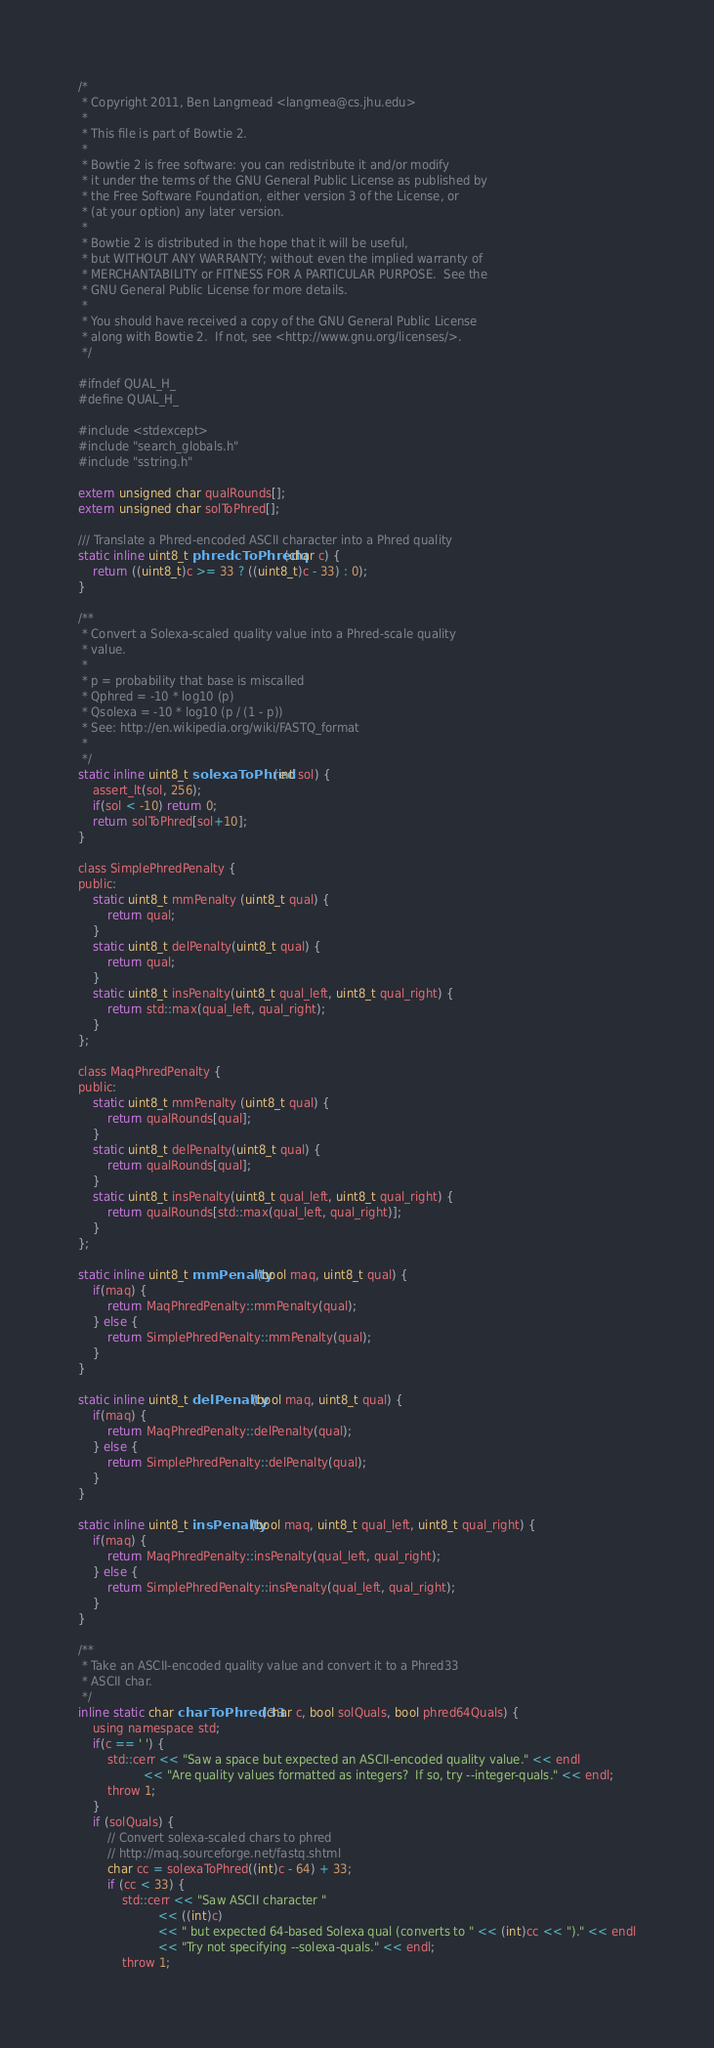Convert code to text. <code><loc_0><loc_0><loc_500><loc_500><_C_>/*
 * Copyright 2011, Ben Langmead <langmea@cs.jhu.edu>
 *
 * This file is part of Bowtie 2.
 *
 * Bowtie 2 is free software: you can redistribute it and/or modify
 * it under the terms of the GNU General Public License as published by
 * the Free Software Foundation, either version 3 of the License, or
 * (at your option) any later version.
 *
 * Bowtie 2 is distributed in the hope that it will be useful,
 * but WITHOUT ANY WARRANTY; without even the implied warranty of
 * MERCHANTABILITY or FITNESS FOR A PARTICULAR PURPOSE.  See the
 * GNU General Public License for more details.
 *
 * You should have received a copy of the GNU General Public License
 * along with Bowtie 2.  If not, see <http://www.gnu.org/licenses/>.
 */

#ifndef QUAL_H_
#define QUAL_H_

#include <stdexcept>
#include "search_globals.h"
#include "sstring.h"

extern unsigned char qualRounds[];
extern unsigned char solToPhred[];

/// Translate a Phred-encoded ASCII character into a Phred quality
static inline uint8_t phredcToPhredq(char c) {
	return ((uint8_t)c >= 33 ? ((uint8_t)c - 33) : 0);
}

/**
 * Convert a Solexa-scaled quality value into a Phred-scale quality
 * value.
 *
 * p = probability that base is miscalled
 * Qphred = -10 * log10 (p)
 * Qsolexa = -10 * log10 (p / (1 - p))
 * See: http://en.wikipedia.org/wiki/FASTQ_format
 *
 */
static inline uint8_t solexaToPhred(int sol) {
	assert_lt(sol, 256);
	if(sol < -10) return 0;
	return solToPhred[sol+10];
}

class SimplePhredPenalty {
public:
	static uint8_t mmPenalty (uint8_t qual) {
		return qual;
	}
	static uint8_t delPenalty(uint8_t qual) {
		return qual;
	}
	static uint8_t insPenalty(uint8_t qual_left, uint8_t qual_right) {
		return std::max(qual_left, qual_right);
	}
};

class MaqPhredPenalty {
public:
	static uint8_t mmPenalty (uint8_t qual) {
		return qualRounds[qual];
	}
	static uint8_t delPenalty(uint8_t qual) {
		return qualRounds[qual];
	}
	static uint8_t insPenalty(uint8_t qual_left, uint8_t qual_right) {
		return qualRounds[std::max(qual_left, qual_right)];
	}
};

static inline uint8_t mmPenalty(bool maq, uint8_t qual) {
	if(maq) {
		return MaqPhredPenalty::mmPenalty(qual);
	} else {
		return SimplePhredPenalty::mmPenalty(qual);
	}
}

static inline uint8_t delPenalty(bool maq, uint8_t qual) {
	if(maq) {
		return MaqPhredPenalty::delPenalty(qual);
	} else {
		return SimplePhredPenalty::delPenalty(qual);
	}
}

static inline uint8_t insPenalty(bool maq, uint8_t qual_left, uint8_t qual_right) {
	if(maq) {
		return MaqPhredPenalty::insPenalty(qual_left, qual_right);
	} else {
		return SimplePhredPenalty::insPenalty(qual_left, qual_right);
	}
}

/**
 * Take an ASCII-encoded quality value and convert it to a Phred33
 * ASCII char.
 */
inline static char charToPhred33(char c, bool solQuals, bool phred64Quals) {
	using namespace std;
	if(c == ' ') {
		std::cerr << "Saw a space but expected an ASCII-encoded quality value." << endl
		          << "Are quality values formatted as integers?  If so, try --integer-quals." << endl;
		throw 1;
	}
	if (solQuals) {
		// Convert solexa-scaled chars to phred
		// http://maq.sourceforge.net/fastq.shtml
		char cc = solexaToPhred((int)c - 64) + 33;
		if (cc < 33) {
			std::cerr << "Saw ASCII character "
			          << ((int)c)
			          << " but expected 64-based Solexa qual (converts to " << (int)cc << ")." << endl
			          << "Try not specifying --solexa-quals." << endl;
			throw 1;</code> 